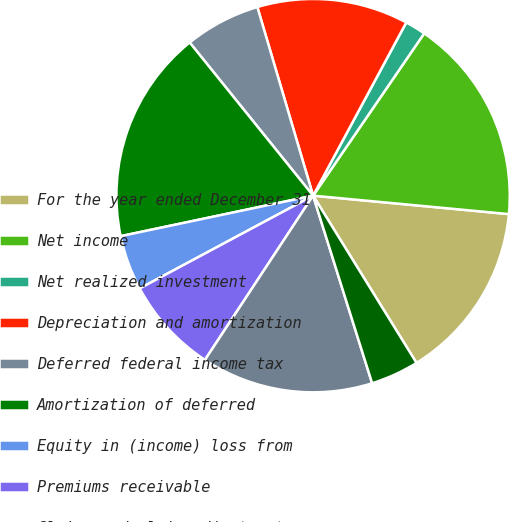<chart> <loc_0><loc_0><loc_500><loc_500><pie_chart><fcel>For the year ended December 31<fcel>Net income<fcel>Net realized investment<fcel>Depreciation and amortization<fcel>Deferred federal income tax<fcel>Amortization of deferred<fcel>Equity in (income) loss from<fcel>Premiums receivable<fcel>Claims and claim adjustment<fcel>Unearned premium reserves<nl><fcel>14.69%<fcel>16.94%<fcel>1.7%<fcel>12.43%<fcel>6.22%<fcel>17.51%<fcel>4.52%<fcel>7.91%<fcel>14.12%<fcel>3.96%<nl></chart> 